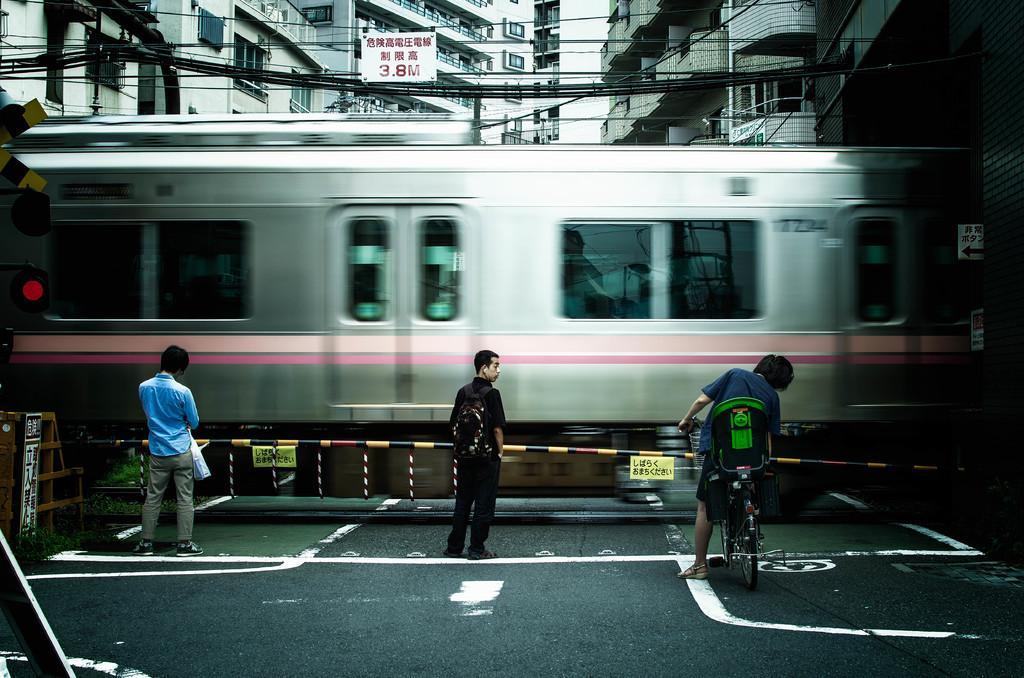Please provide a concise description of this image. Here I can see two people are standing on the road and one person is standing and holding the bicycle in the hands. In front of these people there is a train. On the left side, I can see a traffic signal board and railing. On the top of the image there are some buildings and also I can see some wires. 